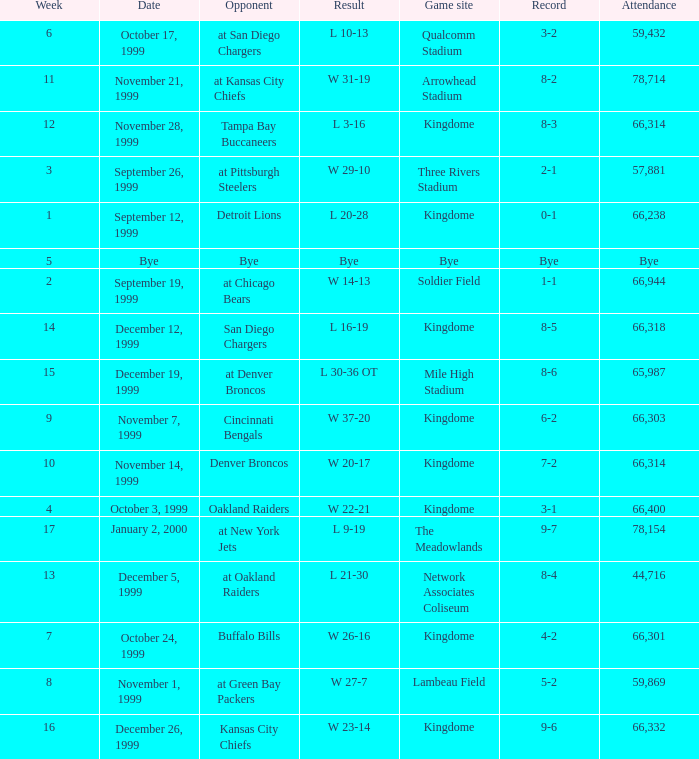What was the result of the game that was played on week 15? L 30-36 OT. 